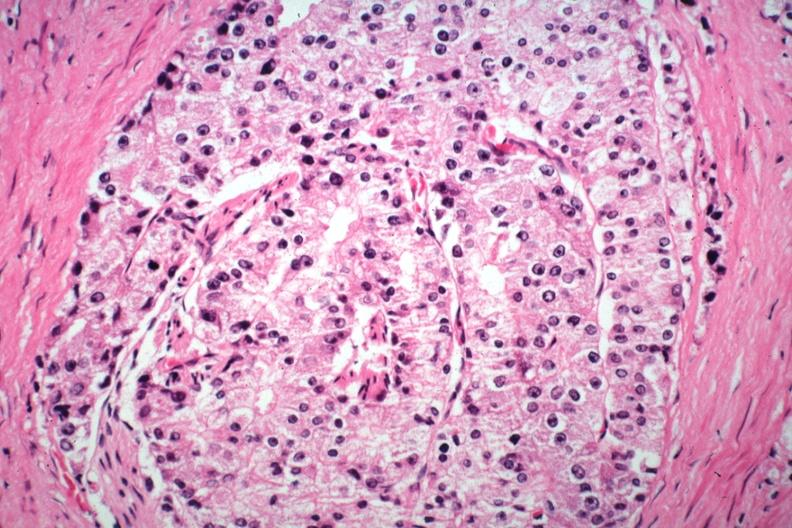s adenocarcinoma present?
Answer the question using a single word or phrase. Yes 